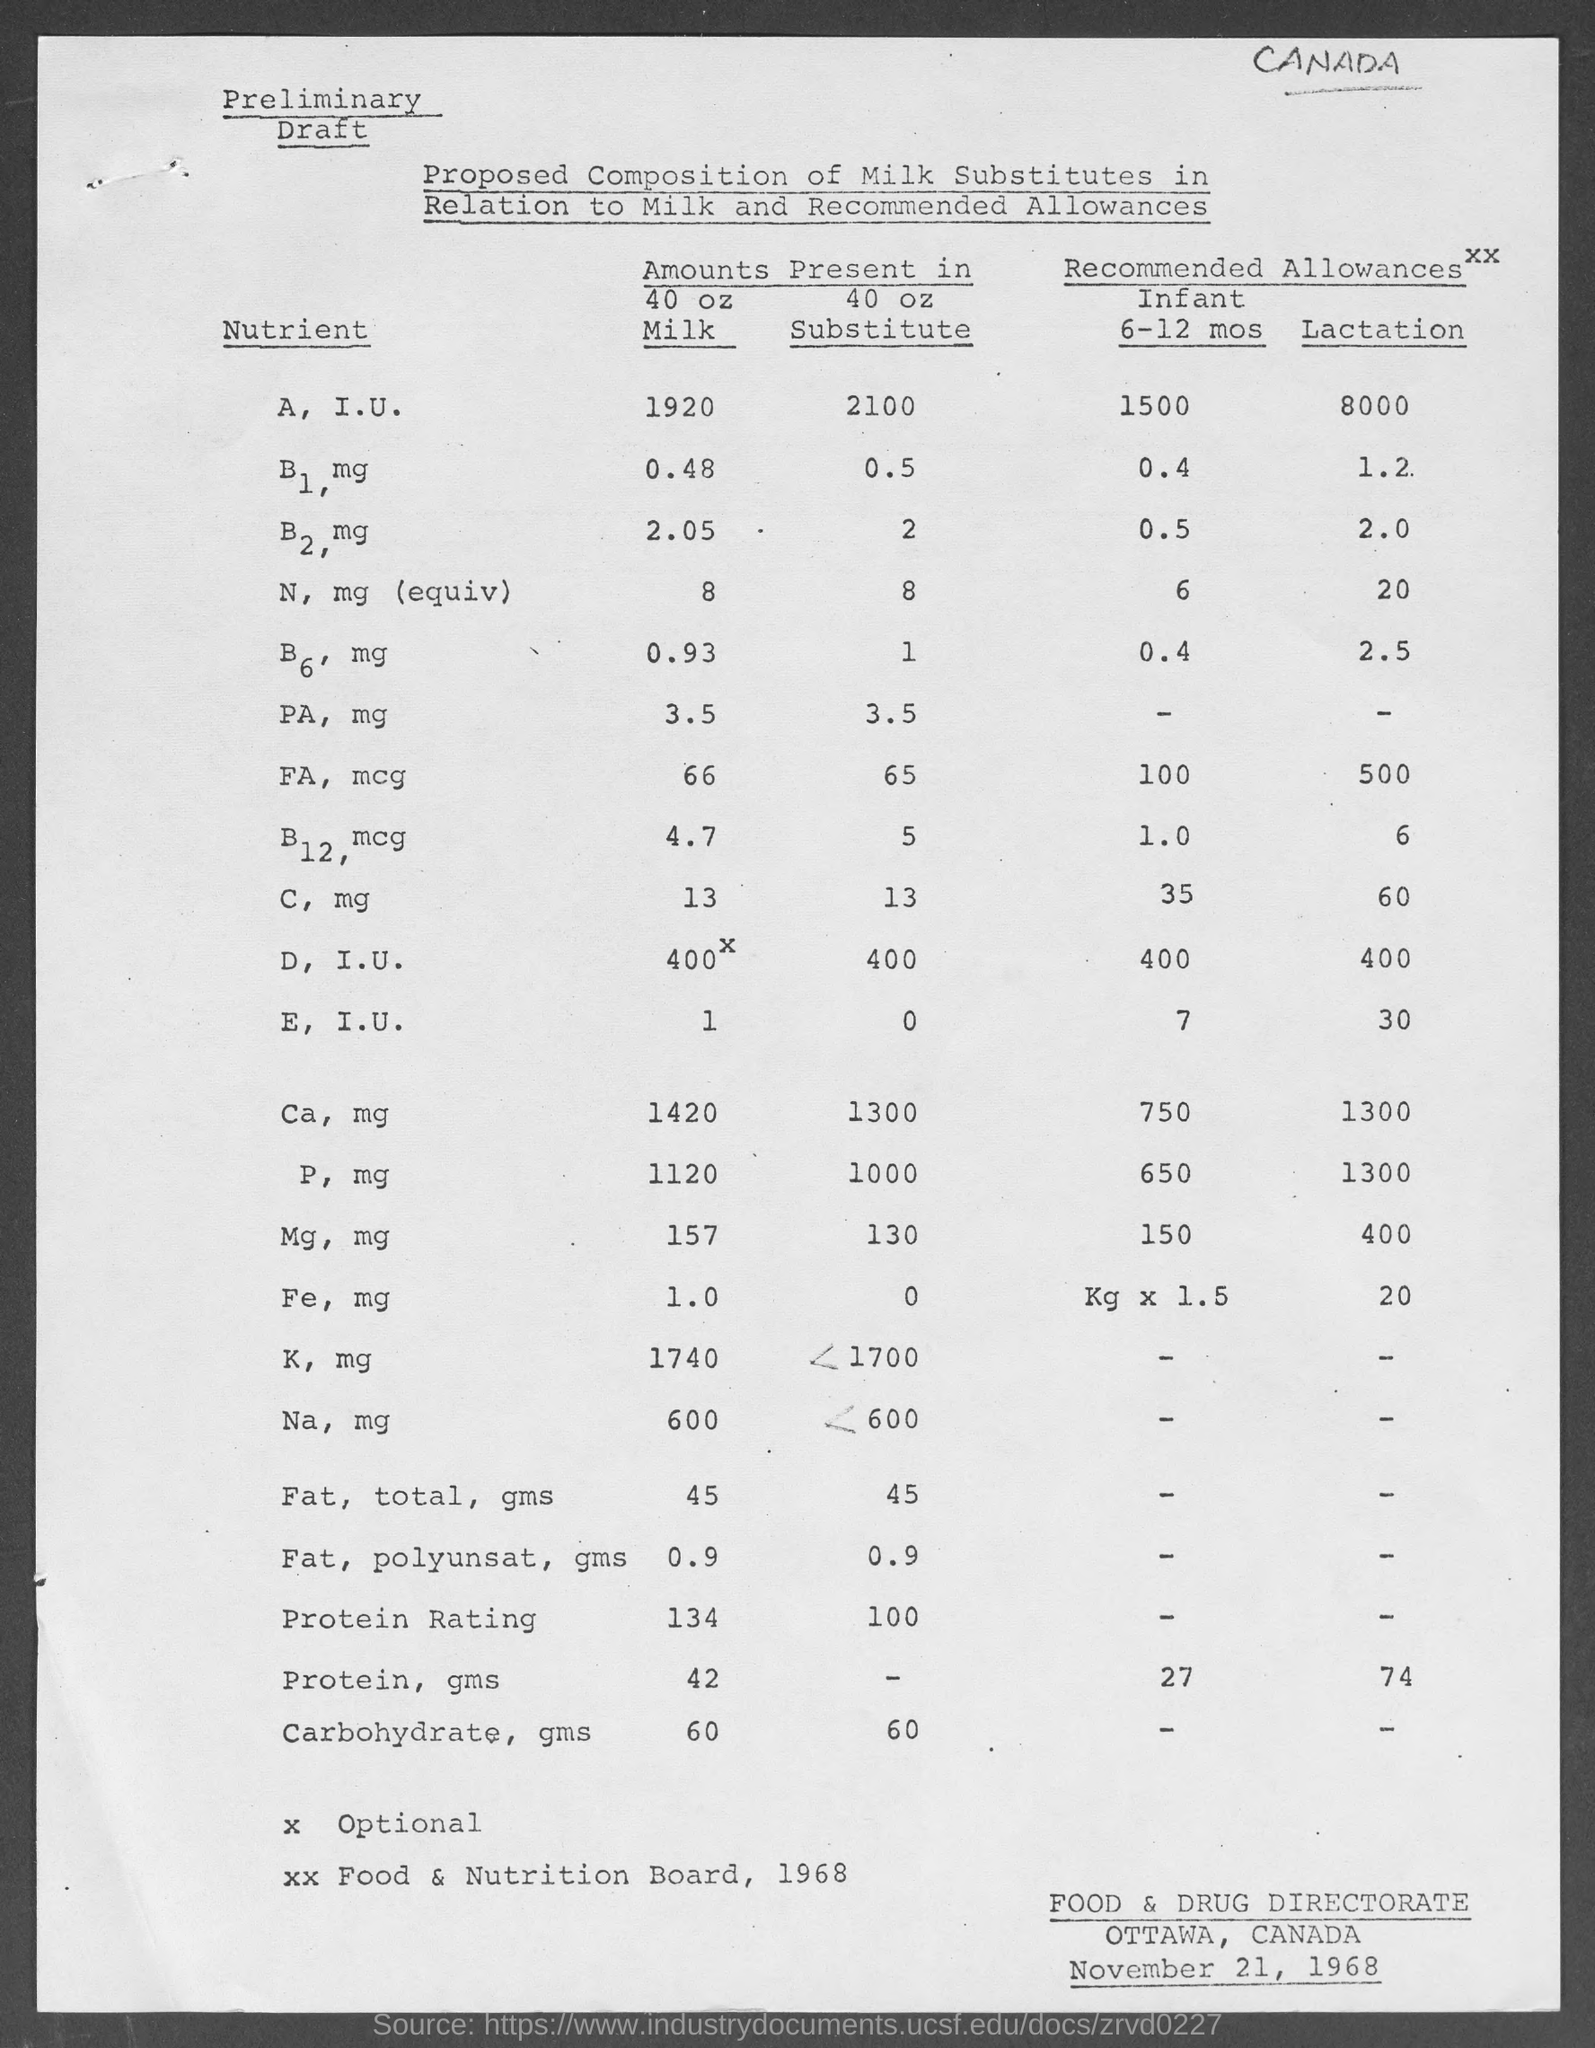List a handful of essential elements in this visual. The amount of C in milk, as mentioned in the provided information, is [value in mg of nutrients]. The amount of vitamin B12, in micrograms (mcg), present in milk, as stated in the provided information, is 4.7. The milk also contains various other nutrients. The amount of vitamin B6, in milligrams (mg), present in the substitute as mentioned in the given form is 1. The given form "November 21, 1968" refers to a specific date. The amount of B2 and the corresponding mg of nutrients present in milk are 2.05... 